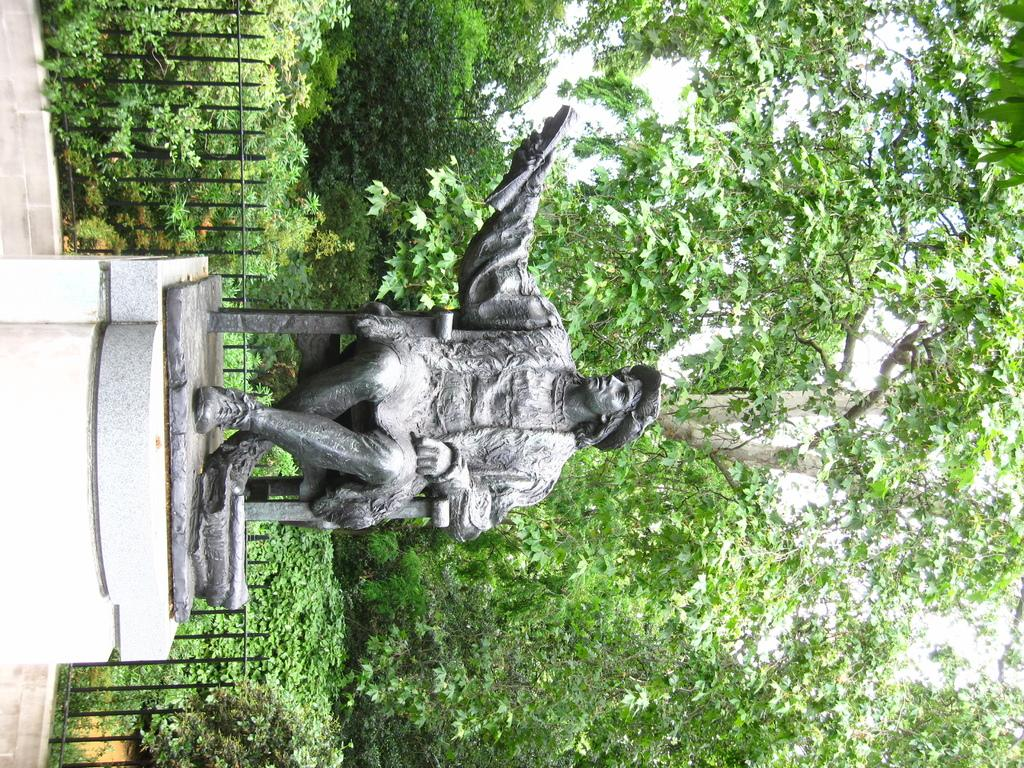What is the main subject of the image? There is a black statue in the image. What is the statue standing on? The statue is on a stone. What can be seen in the background of the image? There is a fence, trees, and plants in the background of the image. What type of poison is being used to protect the plants in the image? There is no mention of poison in the image; the plants are not being protected by any substance. 